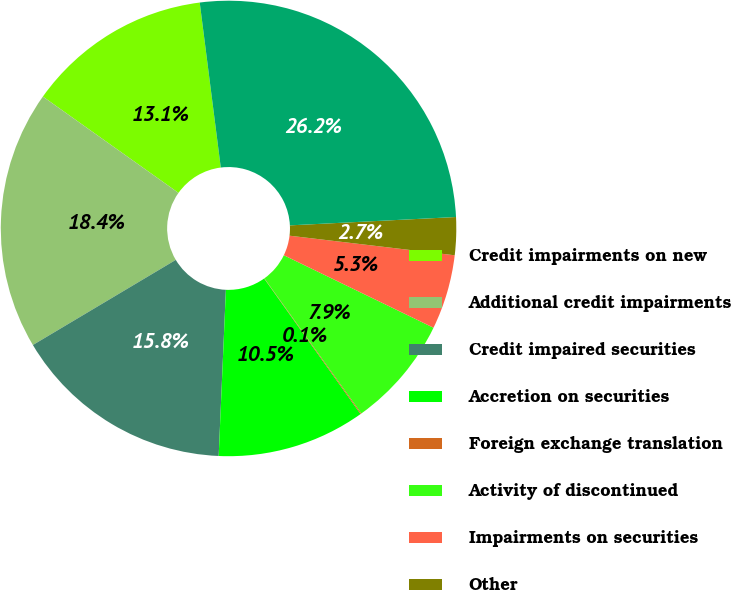Convert chart. <chart><loc_0><loc_0><loc_500><loc_500><pie_chart><fcel>Credit impairments on new<fcel>Additional credit impairments<fcel>Credit impaired securities<fcel>Accretion on securities<fcel>Foreign exchange translation<fcel>Activity of discontinued<fcel>Impairments on securities<fcel>Other<fcel>Balance end of year<nl><fcel>13.15%<fcel>18.38%<fcel>15.76%<fcel>10.53%<fcel>0.07%<fcel>7.91%<fcel>5.3%<fcel>2.68%<fcel>26.22%<nl></chart> 